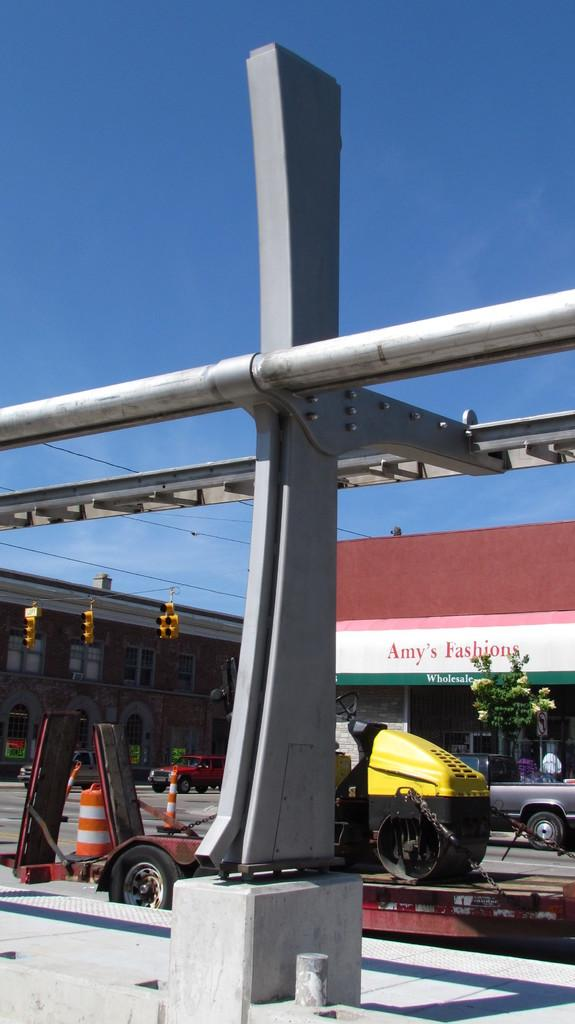What type of objects can be seen in the image? There are metal rods in the image. What can be seen in the distance in the image? There are vehicles, a tree, and buildings visible in the background of the image. What traffic control devices are present in the image? There are traffic lights in the image. Can you see anyone wearing jeans in the image? There is no mention of jeans or any clothing in the image; it primarily focuses on metal rods, traffic lights, and the background elements. 